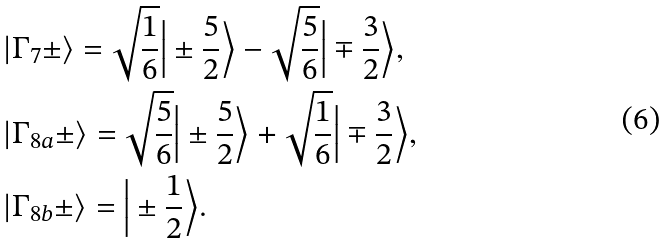<formula> <loc_0><loc_0><loc_500><loc_500>& | \Gamma _ { 7 } \pm \rangle = \sqrt { \frac { 1 } { 6 } } \Big | \pm \frac { 5 } { 2 } \Big \rangle - \sqrt { \frac { 5 } { 6 } } \Big | \mp \frac { 3 } { 2 } \Big \rangle , \\ & | \Gamma _ { 8 a } \pm \rangle = \sqrt { \frac { 5 } { 6 } } \Big | \pm \frac { 5 } { 2 } \Big \rangle + \sqrt { \frac { 1 } { 6 } } \Big | \mp \frac { 3 } { 2 } \Big \rangle , \\ & | \Gamma _ { 8 b } \pm \rangle = \Big | \pm \frac { 1 } { 2 } \Big \rangle .</formula> 